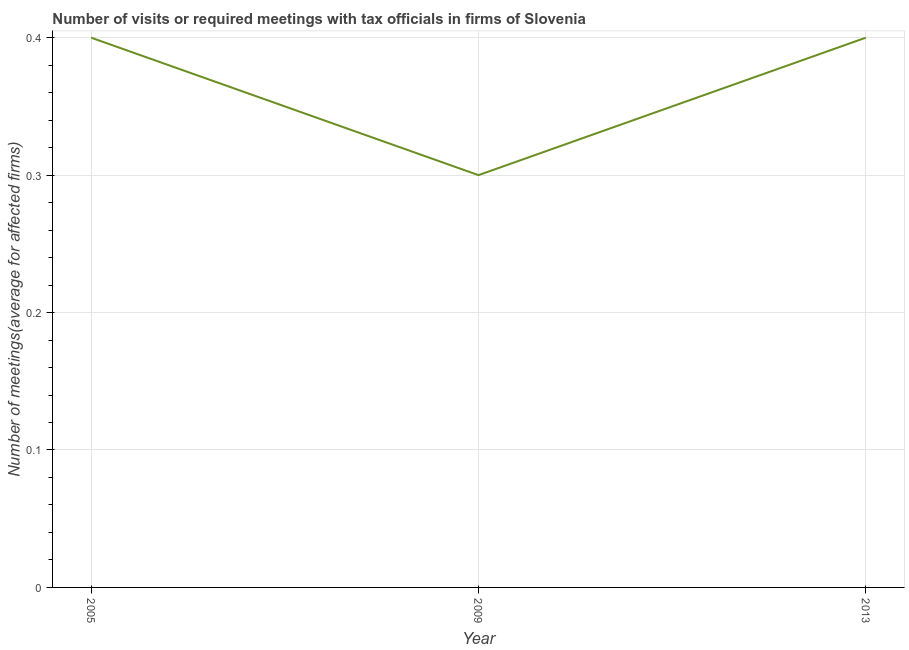Across all years, what is the minimum number of required meetings with tax officials?
Your answer should be compact. 0.3. What is the sum of the number of required meetings with tax officials?
Keep it short and to the point. 1.1. What is the difference between the number of required meetings with tax officials in 2009 and 2013?
Provide a short and direct response. -0.1. What is the average number of required meetings with tax officials per year?
Provide a succinct answer. 0.37. In how many years, is the number of required meetings with tax officials greater than 0.1 ?
Provide a succinct answer. 3. Do a majority of the years between 2013 and 2009 (inclusive) have number of required meetings with tax officials greater than 0.28 ?
Offer a very short reply. No. What is the ratio of the number of required meetings with tax officials in 2005 to that in 2009?
Ensure brevity in your answer.  1.33. Is the number of required meetings with tax officials in 2009 less than that in 2013?
Your response must be concise. Yes. Is the difference between the number of required meetings with tax officials in 2009 and 2013 greater than the difference between any two years?
Provide a succinct answer. Yes. What is the difference between the highest and the lowest number of required meetings with tax officials?
Offer a terse response. 0.1. In how many years, is the number of required meetings with tax officials greater than the average number of required meetings with tax officials taken over all years?
Your answer should be compact. 2. Does the number of required meetings with tax officials monotonically increase over the years?
Keep it short and to the point. No. How many years are there in the graph?
Provide a succinct answer. 3. Does the graph contain grids?
Offer a very short reply. Yes. What is the title of the graph?
Provide a short and direct response. Number of visits or required meetings with tax officials in firms of Slovenia. What is the label or title of the Y-axis?
Offer a terse response. Number of meetings(average for affected firms). What is the Number of meetings(average for affected firms) of 2005?
Your answer should be compact. 0.4. What is the Number of meetings(average for affected firms) in 2013?
Make the answer very short. 0.4. What is the difference between the Number of meetings(average for affected firms) in 2005 and 2009?
Provide a short and direct response. 0.1. What is the difference between the Number of meetings(average for affected firms) in 2009 and 2013?
Keep it short and to the point. -0.1. What is the ratio of the Number of meetings(average for affected firms) in 2005 to that in 2009?
Offer a very short reply. 1.33. 